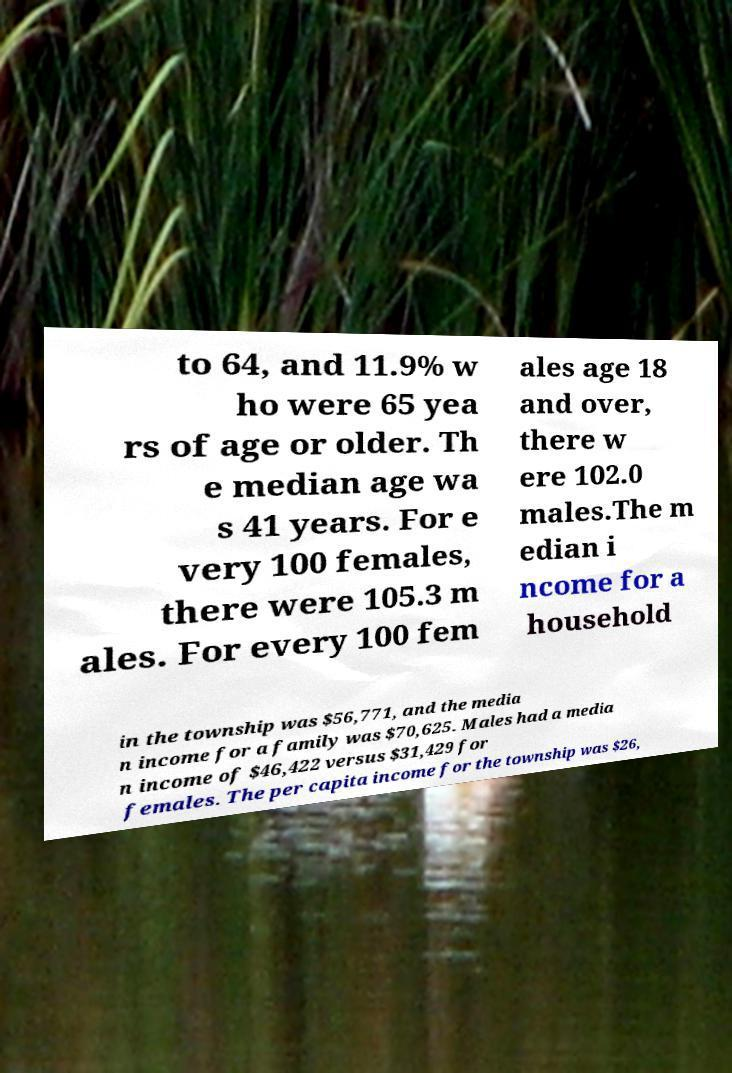Could you extract and type out the text from this image? to 64, and 11.9% w ho were 65 yea rs of age or older. Th e median age wa s 41 years. For e very 100 females, there were 105.3 m ales. For every 100 fem ales age 18 and over, there w ere 102.0 males.The m edian i ncome for a household in the township was $56,771, and the media n income for a family was $70,625. Males had a media n income of $46,422 versus $31,429 for females. The per capita income for the township was $26, 